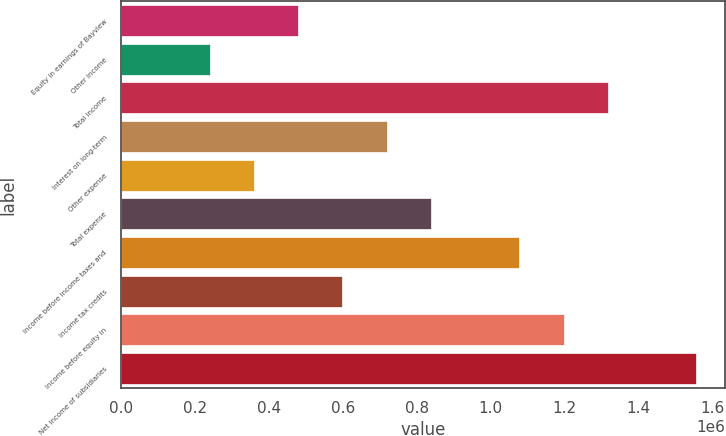<chart> <loc_0><loc_0><loc_500><loc_500><bar_chart><fcel>Equity in earnings of Bayview<fcel>Other income<fcel>Total income<fcel>Interest on long-term<fcel>Other expense<fcel>Total expense<fcel>Income before income taxes and<fcel>Income tax credits<fcel>Income before equity in<fcel>Net income of subsidiaries<nl><fcel>479100<fcel>239554<fcel>1.31751e+06<fcel>718645<fcel>359327<fcel>838418<fcel>1.07796e+06<fcel>598873<fcel>1.19774e+06<fcel>1.55706e+06<nl></chart> 